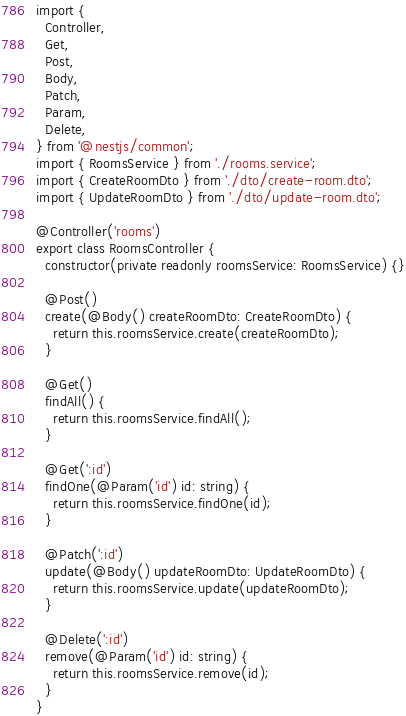Convert code to text. <code><loc_0><loc_0><loc_500><loc_500><_TypeScript_>import {
  Controller,
  Get,
  Post,
  Body,
  Patch,
  Param,
  Delete,
} from '@nestjs/common';
import { RoomsService } from './rooms.service';
import { CreateRoomDto } from './dto/create-room.dto';
import { UpdateRoomDto } from './dto/update-room.dto';

@Controller('rooms')
export class RoomsController {
  constructor(private readonly roomsService: RoomsService) {}

  @Post()
  create(@Body() createRoomDto: CreateRoomDto) {
    return this.roomsService.create(createRoomDto);
  }

  @Get()
  findAll() {
    return this.roomsService.findAll();
  }

  @Get(':id')
  findOne(@Param('id') id: string) {
    return this.roomsService.findOne(id);
  }

  @Patch(':id')
  update(@Body() updateRoomDto: UpdateRoomDto) {
    return this.roomsService.update(updateRoomDto);
  }

  @Delete(':id')
  remove(@Param('id') id: string) {
    return this.roomsService.remove(id);
  }
}
</code> 